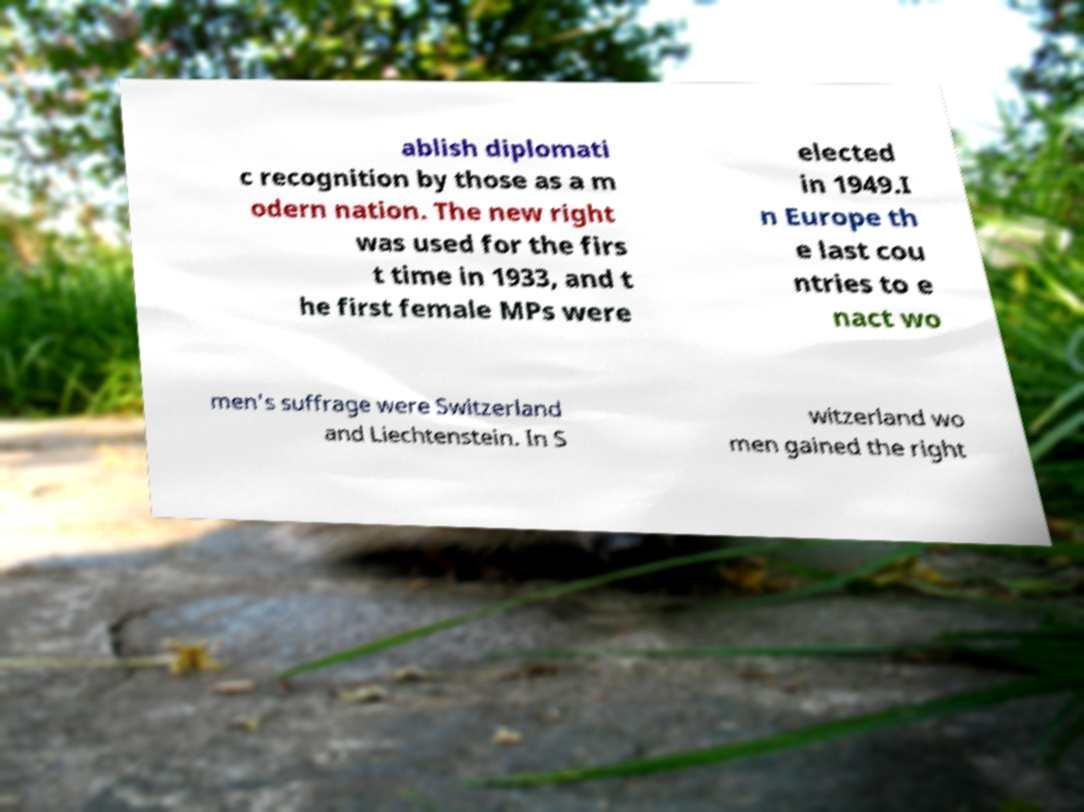Please read and relay the text visible in this image. What does it say? ablish diplomati c recognition by those as a m odern nation. The new right was used for the firs t time in 1933, and t he first female MPs were elected in 1949.I n Europe th e last cou ntries to e nact wo men's suffrage were Switzerland and Liechtenstein. In S witzerland wo men gained the right 